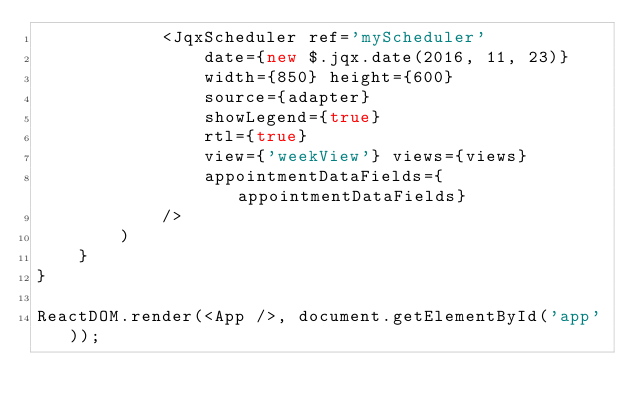<code> <loc_0><loc_0><loc_500><loc_500><_JavaScript_>            <JqxScheduler ref='myScheduler'
                date={new $.jqx.date(2016, 11, 23)}
                width={850} height={600}
                source={adapter}
                showLegend={true}
                rtl={true}
                view={'weekView'} views={views}
                appointmentDataFields={appointmentDataFields}
            />
        )
    }
}

ReactDOM.render(<App />, document.getElementById('app'));
</code> 